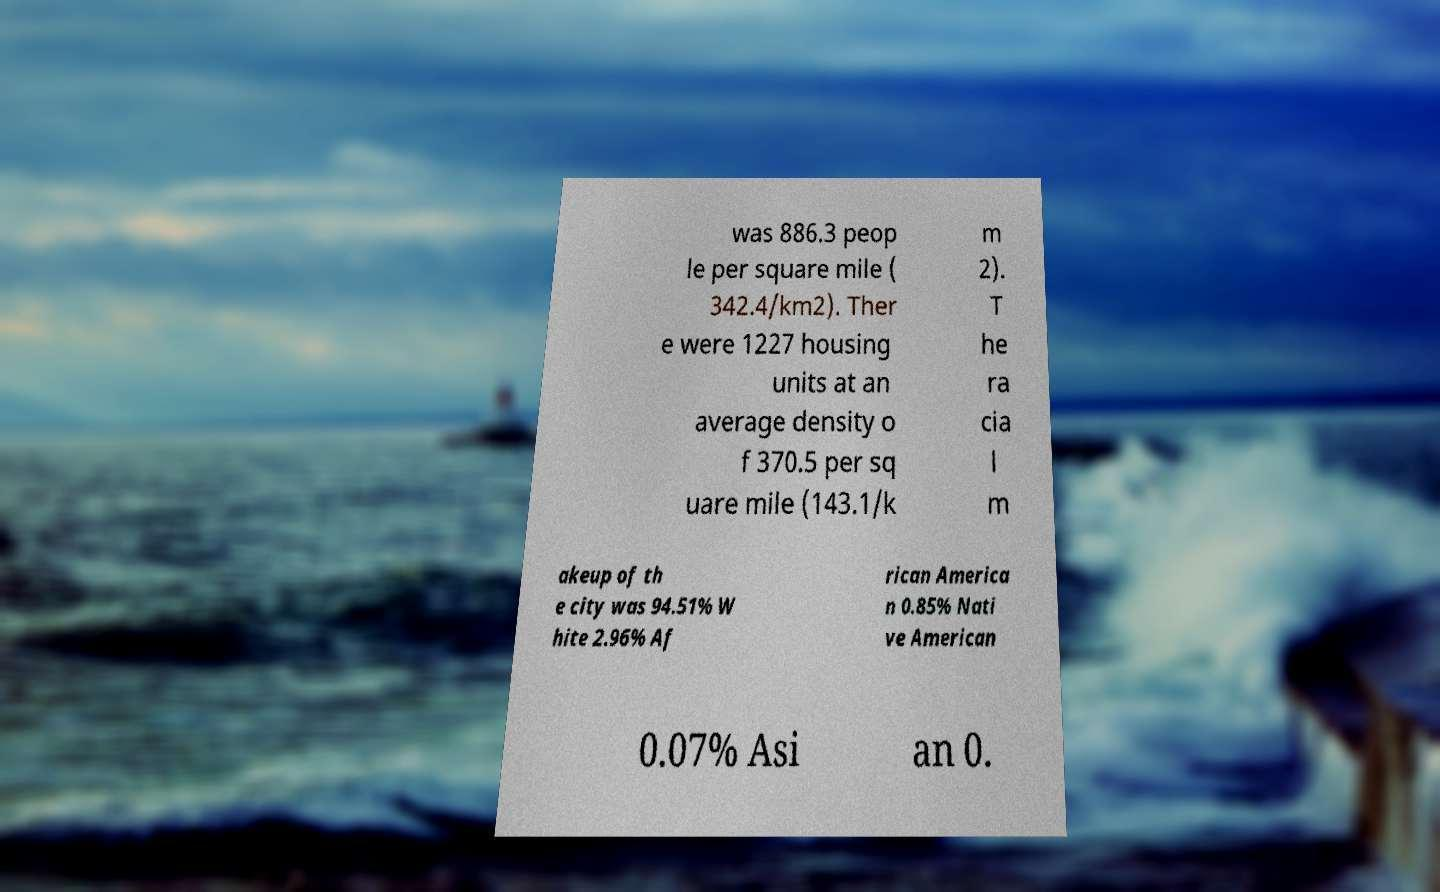There's text embedded in this image that I need extracted. Can you transcribe it verbatim? was 886.3 peop le per square mile ( 342.4/km2). Ther e were 1227 housing units at an average density o f 370.5 per sq uare mile (143.1/k m 2). T he ra cia l m akeup of th e city was 94.51% W hite 2.96% Af rican America n 0.85% Nati ve American 0.07% Asi an 0. 